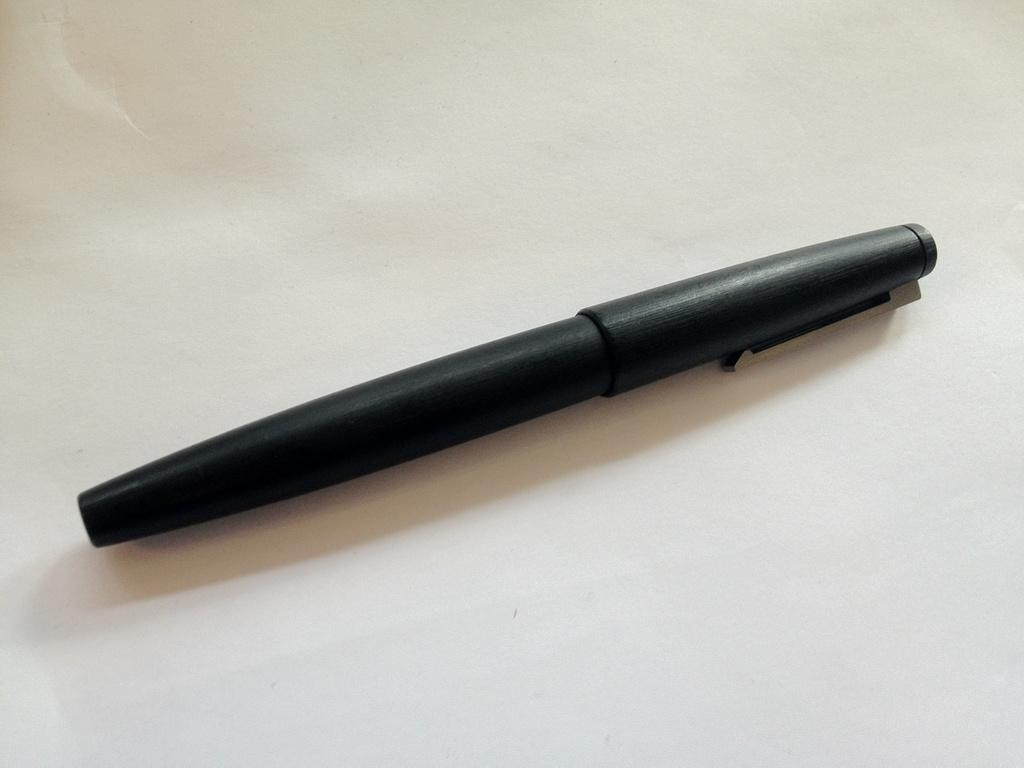What type of writing instrument is visible in the image? There is a black color pen in the image. What color is the background of the image? The background of the image is white. Is there a park visible in the image? No, there is no park present in the image. What type of emotion is being expressed by the pen in the image? The pen is an inanimate object and cannot express emotions like regret. 